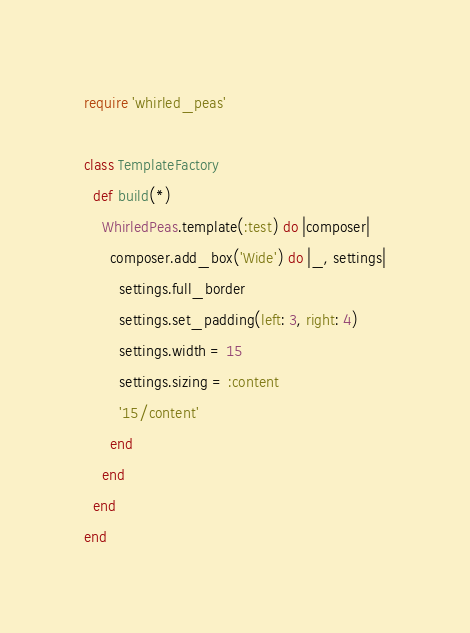Convert code to text. <code><loc_0><loc_0><loc_500><loc_500><_Ruby_>require 'whirled_peas'

class TemplateFactory
  def build(*)
    WhirledPeas.template(:test) do |composer|
      composer.add_box('Wide') do |_, settings|
        settings.full_border
        settings.set_padding(left: 3, right: 4)
        settings.width = 15
        settings.sizing = :content
        '15/content'
      end
    end
  end
end
</code> 